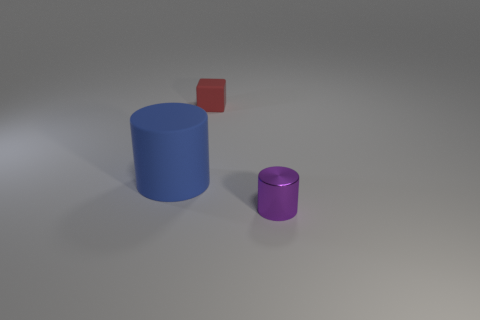Add 2 blue matte cylinders. How many objects exist? 5 Subtract all cylinders. How many objects are left? 1 Subtract 0 blue spheres. How many objects are left? 3 Subtract all tiny cyan metal blocks. Subtract all big blue rubber cylinders. How many objects are left? 2 Add 1 tiny objects. How many tiny objects are left? 3 Add 3 tiny red blocks. How many tiny red blocks exist? 4 